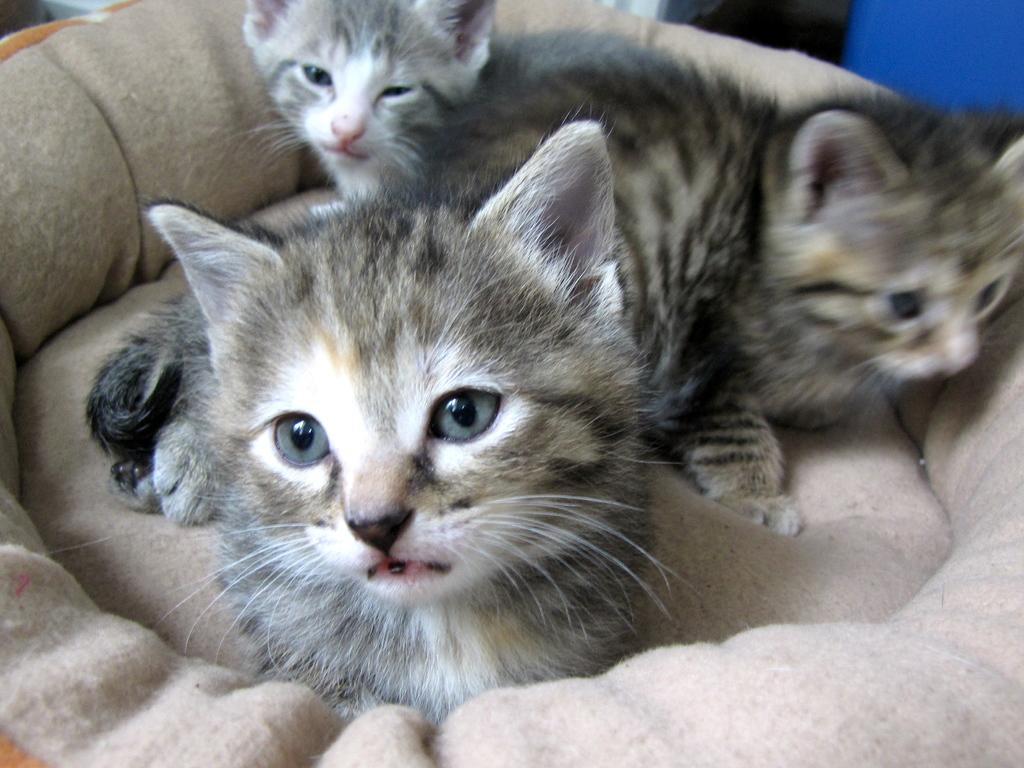Could you give a brief overview of what you see in this image? In this image we can see three cats on a couch. 